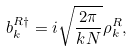Convert formula to latex. <formula><loc_0><loc_0><loc_500><loc_500>b _ { k } ^ { R \dagger } = i \sqrt { \frac { 2 \pi } { k N } } \rho _ { k } ^ { R } ,</formula> 